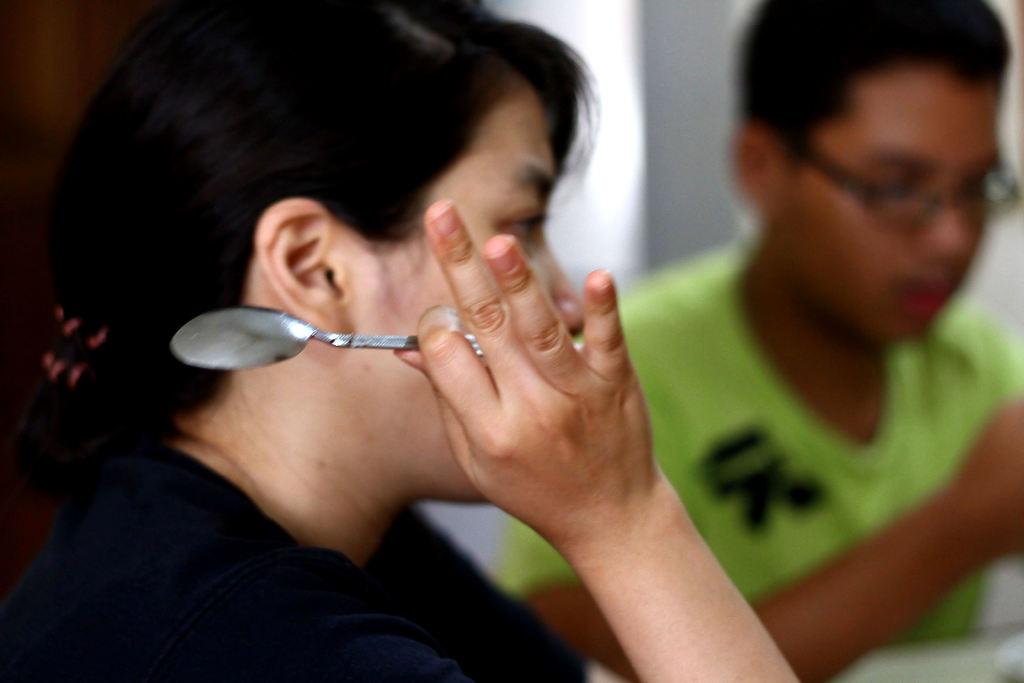What is the gender of the person in the image? There is a woman in the image. What is the woman holding in the image? The woman is holding a spoon. Are there any other people in the image? Yes, there is a man in the image. What can be seen in the background of the image? There is a wall in the image. Can you see any snails on the wall in the image? There are no snails visible on the wall in the image. What type of observation can be made about the cobweb on the ceiling in the image? There is no cobweb present on the ceiling in the image. 